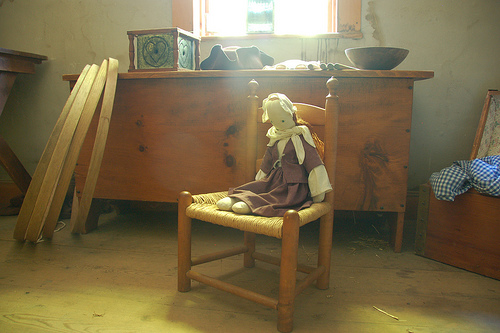<image>
Is there a doll on the floor? No. The doll is not positioned on the floor. They may be near each other, but the doll is not supported by or resting on top of the floor. 